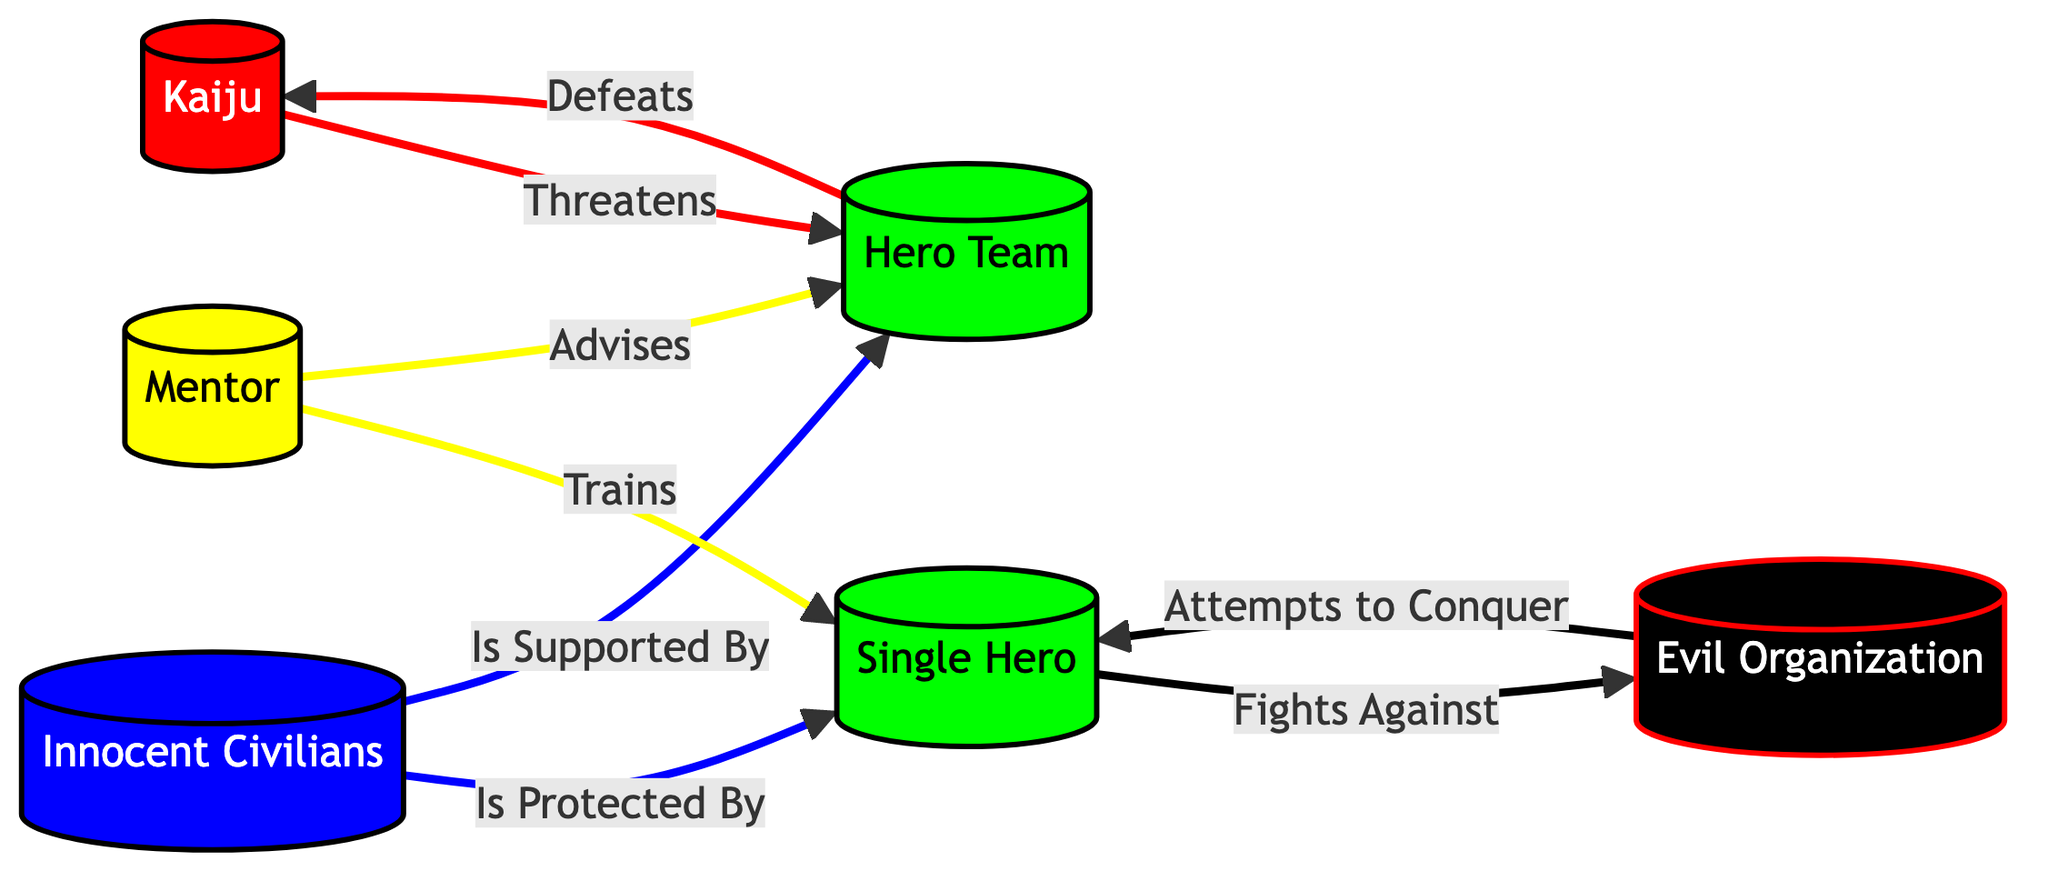What node threatens the hero team? The diagram directly indicates that the kaiju poses a threat to the hero team, as seen from the arrow labeled "Threatens."
Answer: Kaiju How many types of protagonists are there in the ecosystem? The diagram includes the hero team and single hero as types of protagonists. This totals to 2 types.
Answer: 2 What does the mentor do for the single hero? The diagram shows that the mentor trains the single hero, which is indicated by the directed link labeled "Trains."
Answer: Trains Who does the single hero fight against? According to the diagram, the single hero fights against the evil organization, as represented by the arrow labeled "Fights Against."
Answer: Evil Organization What relationship exists between innocent civilians and the hero team? The diagram illustrates that innocent civilians are supported by the hero team, as indicated by the connection labeled "Is Supported By."
Answer: Supported By 